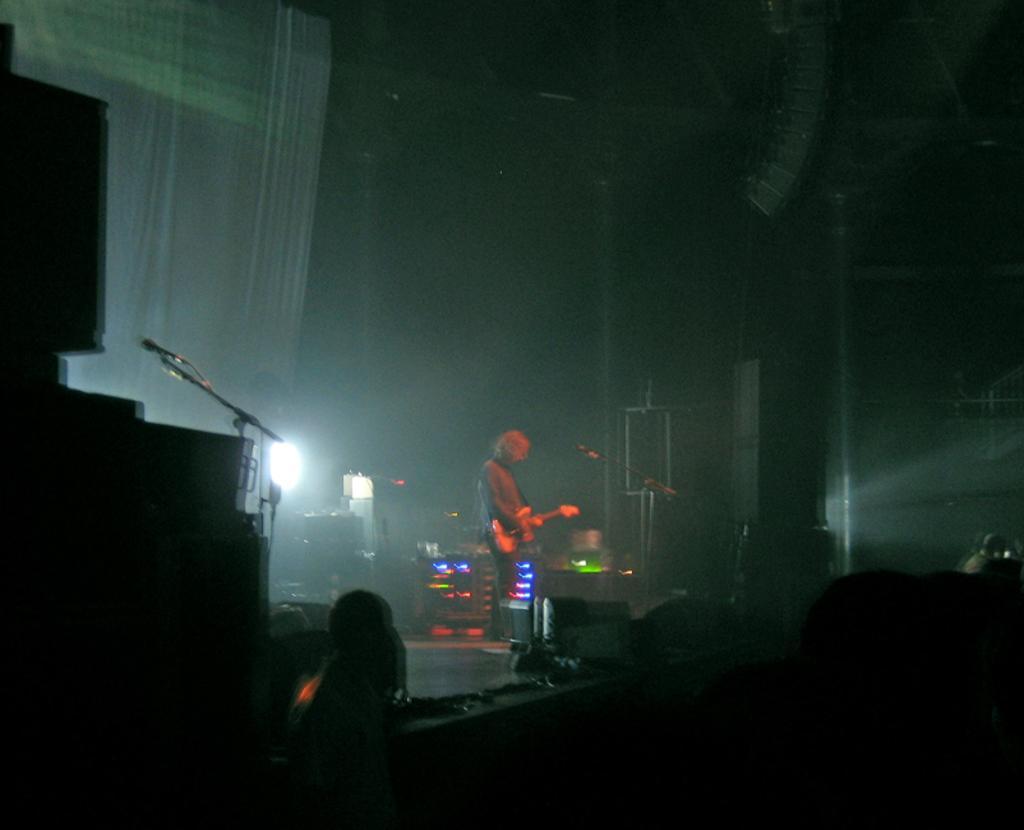Please provide a concise description of this image. In this image we can see a man is playing guitar on the stage. At the bottom of the image, we can see people. In the background, we can see curtain and so many objects. On the stage, we can see stands and mics. 